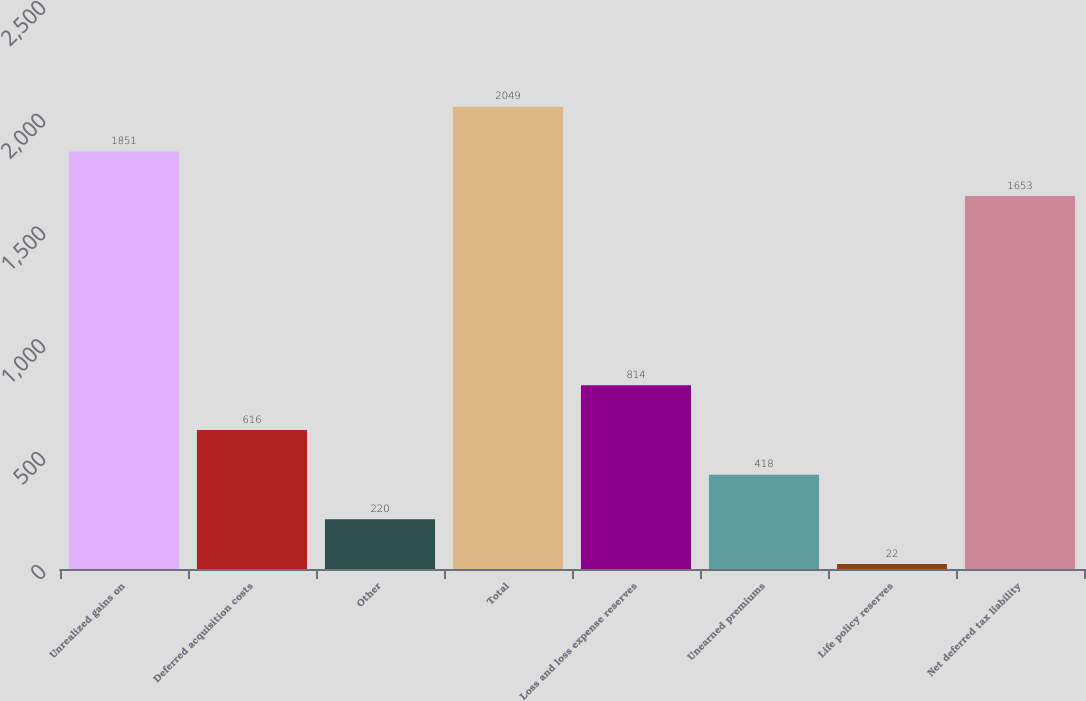<chart> <loc_0><loc_0><loc_500><loc_500><bar_chart><fcel>Unrealized gains on<fcel>Deferred acquisition costs<fcel>Other<fcel>Total<fcel>Loss and loss expense reserves<fcel>Unearned premiums<fcel>Life policy reserves<fcel>Net deferred tax liability<nl><fcel>1851<fcel>616<fcel>220<fcel>2049<fcel>814<fcel>418<fcel>22<fcel>1653<nl></chart> 